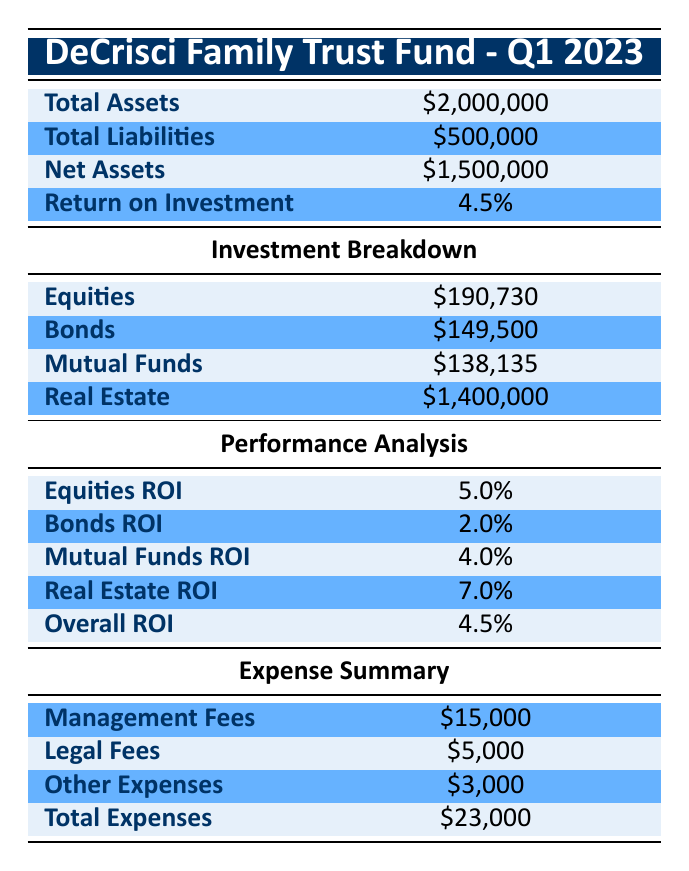What is the total value of the equities investment? The total value of the equities investment is explicitly listed in the table under the investment breakdown. It is \$190,730.
Answer: 190730 What are the total expenses incurred by the trust fund? The total expenses are stated in the expense summary section of the table. They are listed as \$23,000.
Answer: 23000 Which investment type has the highest return on investment? From the performance analysis section, the return on investment for real estate is 7.0%, which is higher than the others listed.
Answer: Real Estate What is the net asset value of the DeCrisci Family Trust Fund? The net assets are calculated by subtracting total liabilities from total assets, which is \$2,000,000 - \$500,000 = \$1,500,000. This is clearly stated in the summary as well.
Answer: 1500000 Is the return on investment for bonds greater than the return on investment for equities? The return on investment for bonds is 2.0% and for equities is 5.0%. Since 2.0% is not greater than 5.0%, the answer is no.
Answer: No What is the total market value of real estate investments? The total market value for real estate is listed in the investment breakdown section as \$1,400,000.
Answer: 1400000 Calculate the total return on investment for all types of investments. The overall return on investment is already calculated in the performance analysis section of the table as 4.5%. Therefore, it's directly stated rather than needing to be calculated again.
Answer: 4.5% How much income is generated from the rental properties? The total rental income from real estate investments is provided in the investment breakdown, showing \$104,000.
Answer: 104000 Does the DeCrisci Family Trust Fund have more liabilities than assets? The total assets are \$2,000,000 and total liabilities are \$500,000. Since \$500,000 is not more than \$2,000,000, the answer is no.
Answer: No 